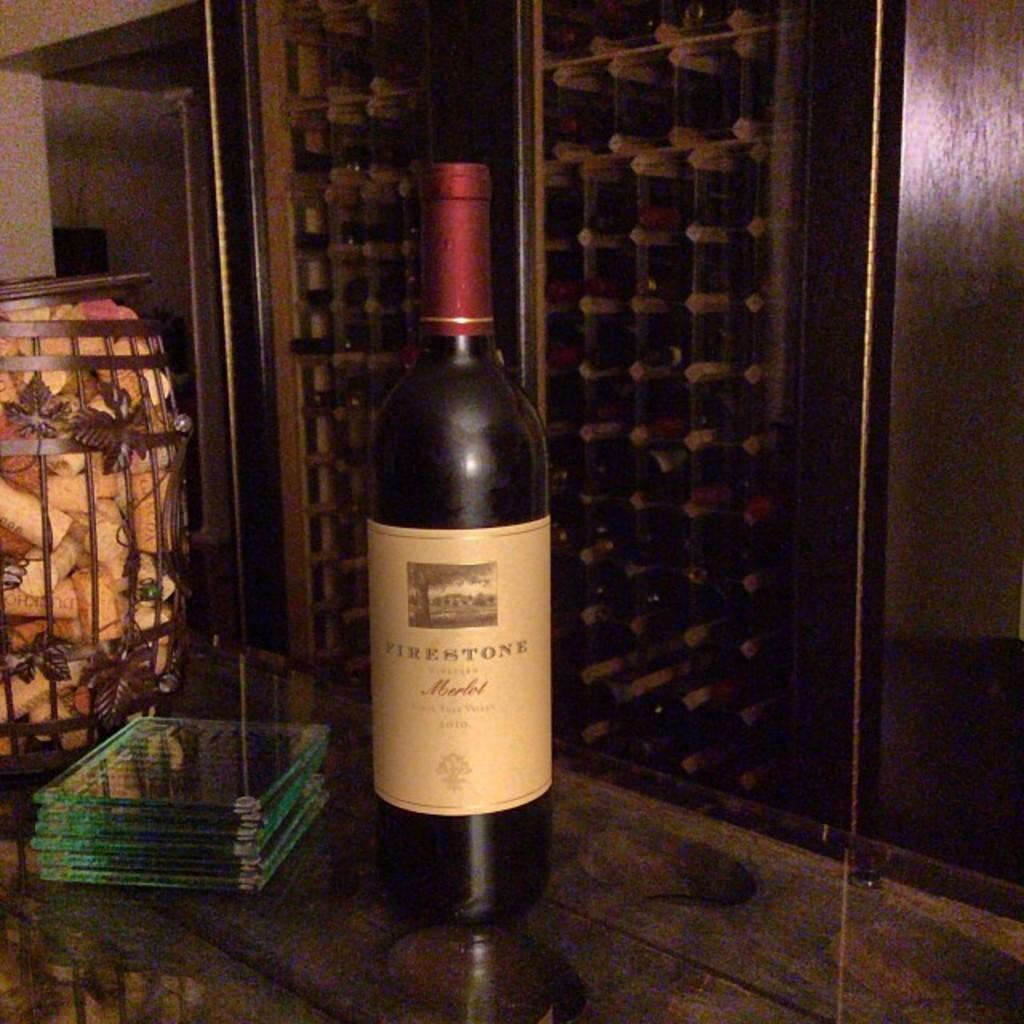<image>
Summarize the visual content of the image. Glass coasters are on a bar, next to a bottle of Firestone Merlot, in a wine cellar. 